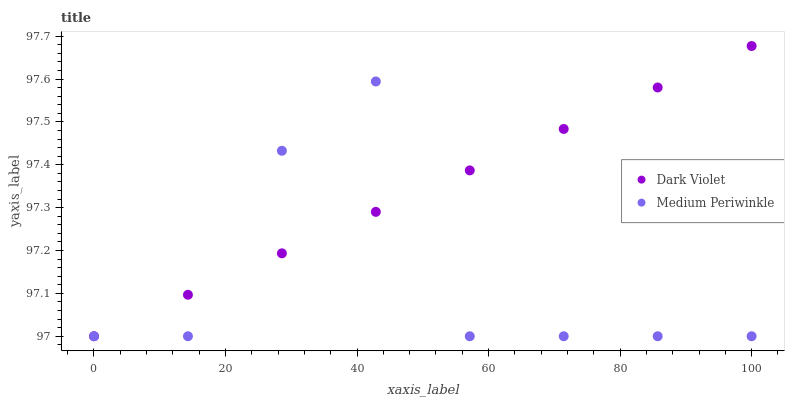Does Medium Periwinkle have the minimum area under the curve?
Answer yes or no. Yes. Does Dark Violet have the maximum area under the curve?
Answer yes or no. Yes. Does Dark Violet have the minimum area under the curve?
Answer yes or no. No. Is Dark Violet the smoothest?
Answer yes or no. Yes. Is Medium Periwinkle the roughest?
Answer yes or no. Yes. Is Dark Violet the roughest?
Answer yes or no. No. Does Medium Periwinkle have the lowest value?
Answer yes or no. Yes. Does Dark Violet have the highest value?
Answer yes or no. Yes. Does Dark Violet intersect Medium Periwinkle?
Answer yes or no. Yes. Is Dark Violet less than Medium Periwinkle?
Answer yes or no. No. Is Dark Violet greater than Medium Periwinkle?
Answer yes or no. No. 